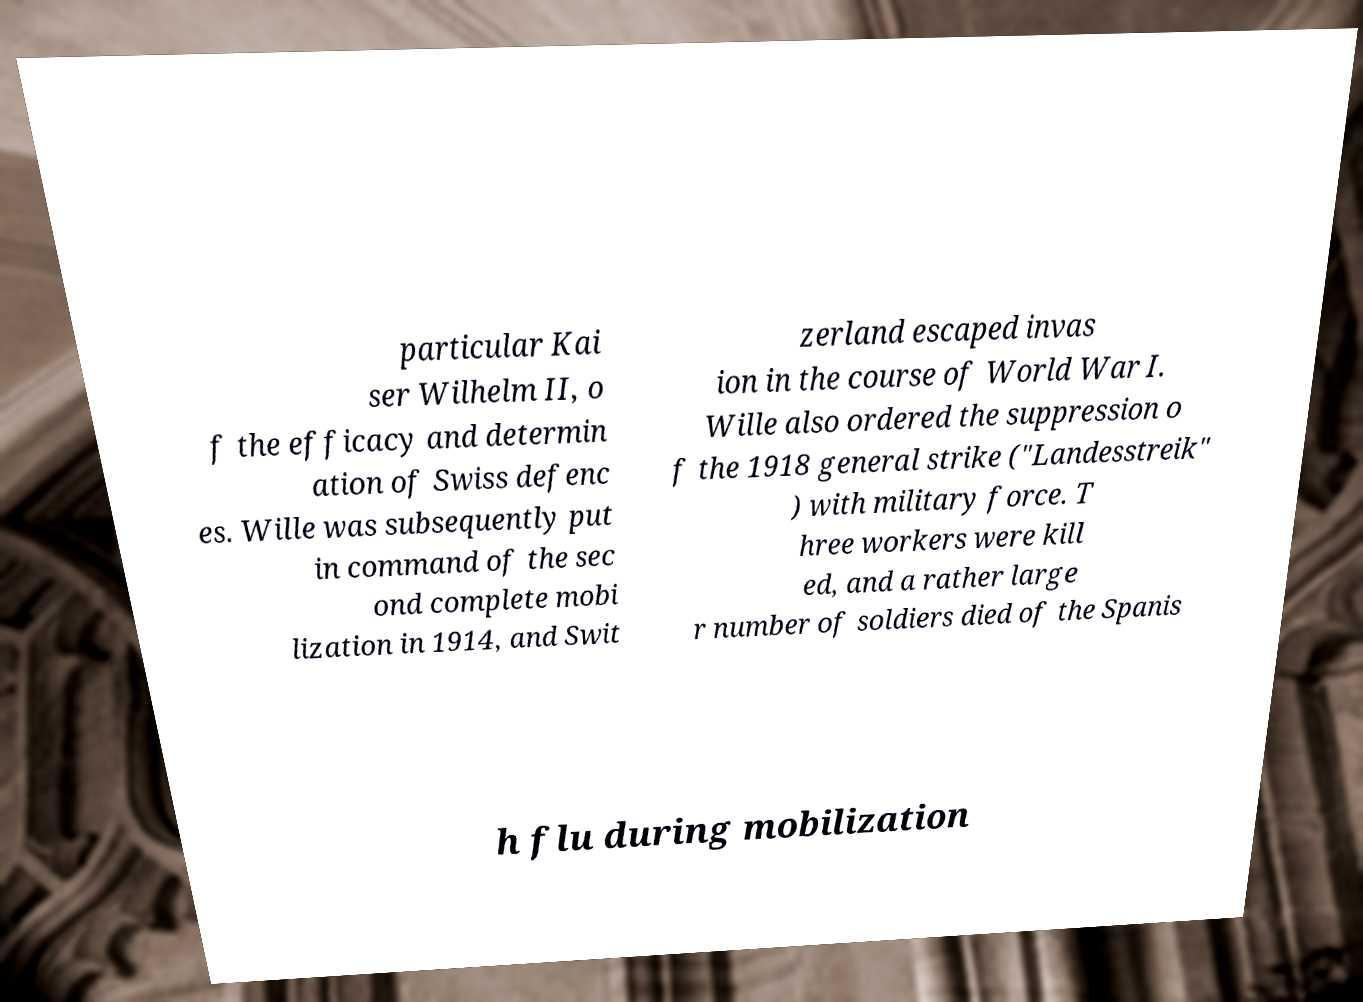Can you read and provide the text displayed in the image?This photo seems to have some interesting text. Can you extract and type it out for me? particular Kai ser Wilhelm II, o f the efficacy and determin ation of Swiss defenc es. Wille was subsequently put in command of the sec ond complete mobi lization in 1914, and Swit zerland escaped invas ion in the course of World War I. Wille also ordered the suppression o f the 1918 general strike ("Landesstreik" ) with military force. T hree workers were kill ed, and a rather large r number of soldiers died of the Spanis h flu during mobilization 